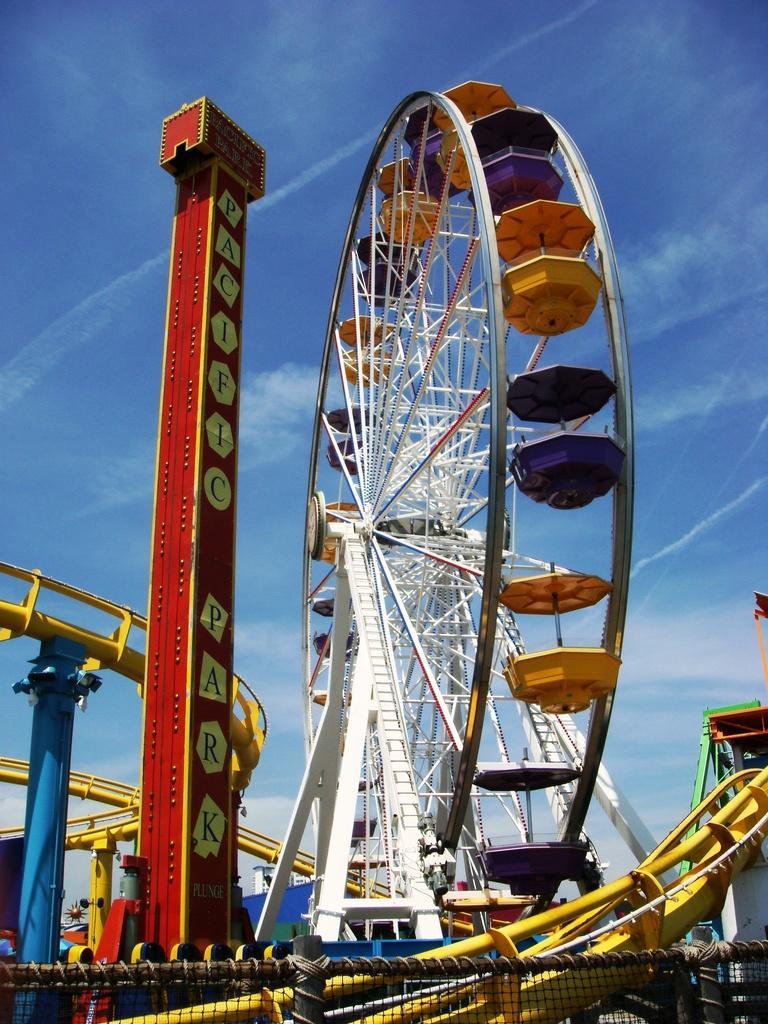Could you give a brief overview of what you see in this image? In this picture I can see a giant wheel and other few rides. I can also see a red color pole in the middle of this picture and I see something is written on it. In the background I can see the clear sky. On the bottom of this picture I can see the fencing. 